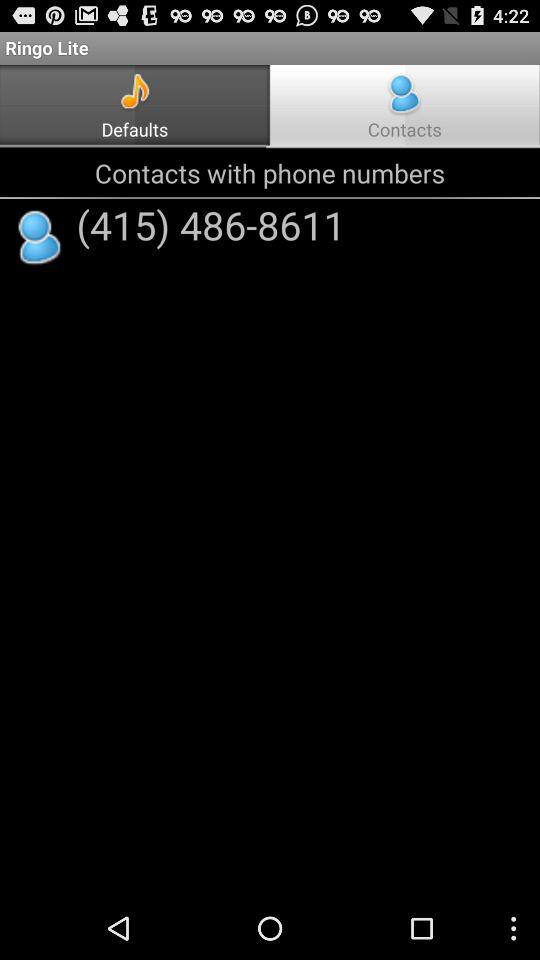What is the contact number? The contact number is (415) 486-8611. 